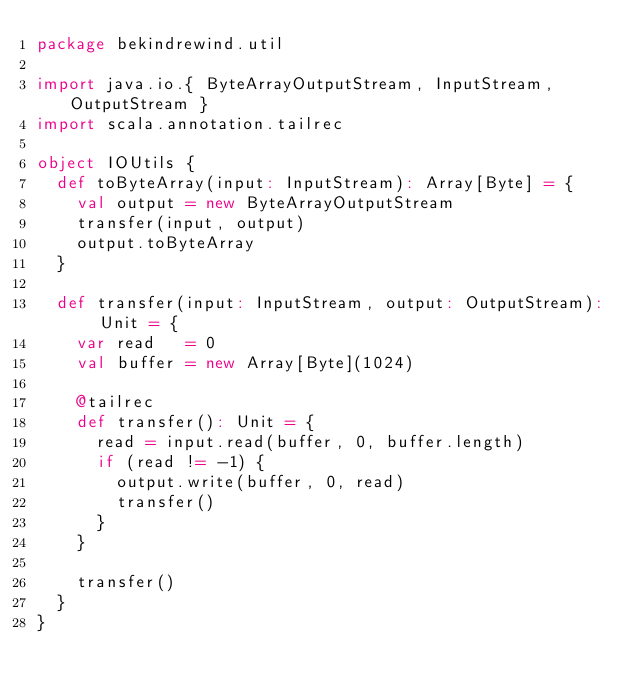<code> <loc_0><loc_0><loc_500><loc_500><_Scala_>package bekindrewind.util

import java.io.{ ByteArrayOutputStream, InputStream, OutputStream }
import scala.annotation.tailrec

object IOUtils {
  def toByteArray(input: InputStream): Array[Byte] = {
    val output = new ByteArrayOutputStream
    transfer(input, output)
    output.toByteArray
  }

  def transfer(input: InputStream, output: OutputStream): Unit = {
    var read   = 0
    val buffer = new Array[Byte](1024)

    @tailrec
    def transfer(): Unit = {
      read = input.read(buffer, 0, buffer.length)
      if (read != -1) {
        output.write(buffer, 0, read)
        transfer()
      }
    }

    transfer()
  }
}
</code> 